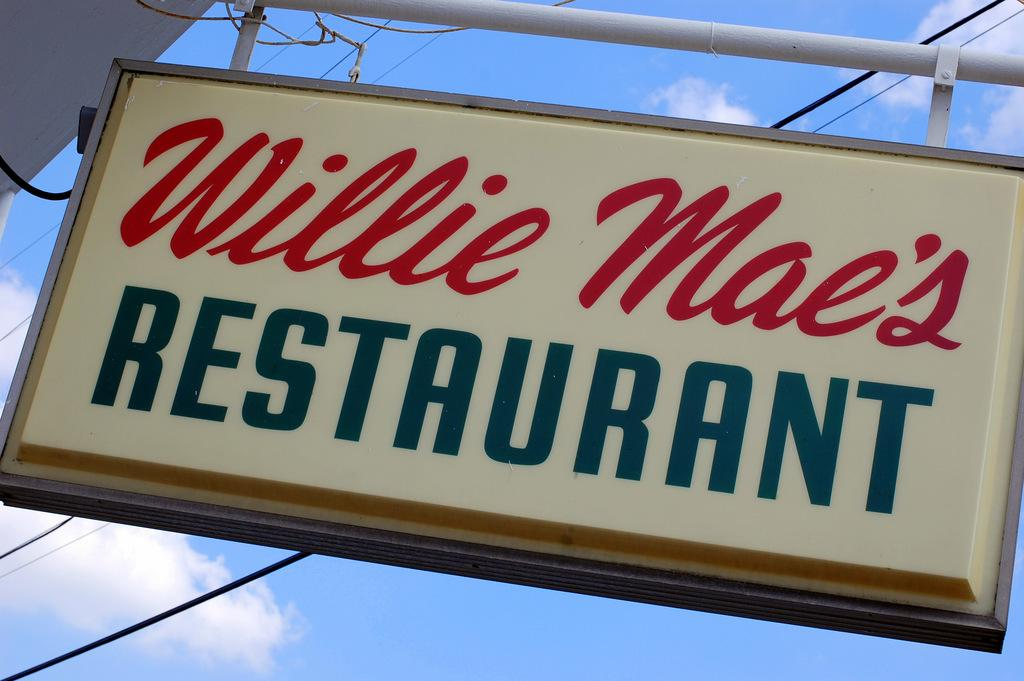<image>
Relay a brief, clear account of the picture shown. White Willie Mae's restaurant sign outdoors on a sunny day. 